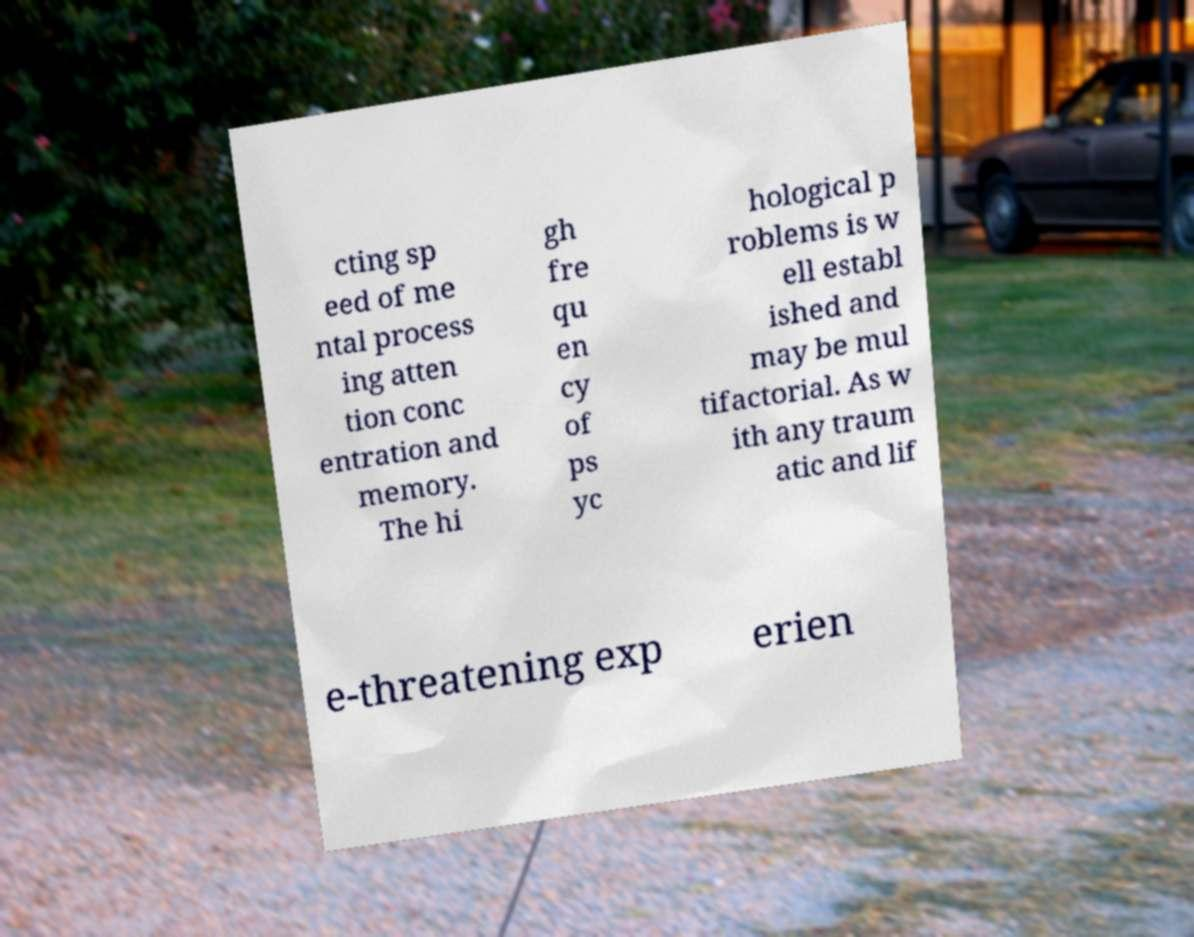What messages or text are displayed in this image? I need them in a readable, typed format. cting sp eed of me ntal process ing atten tion conc entration and memory. The hi gh fre qu en cy of ps yc hological p roblems is w ell establ ished and may be mul tifactorial. As w ith any traum atic and lif e-threatening exp erien 